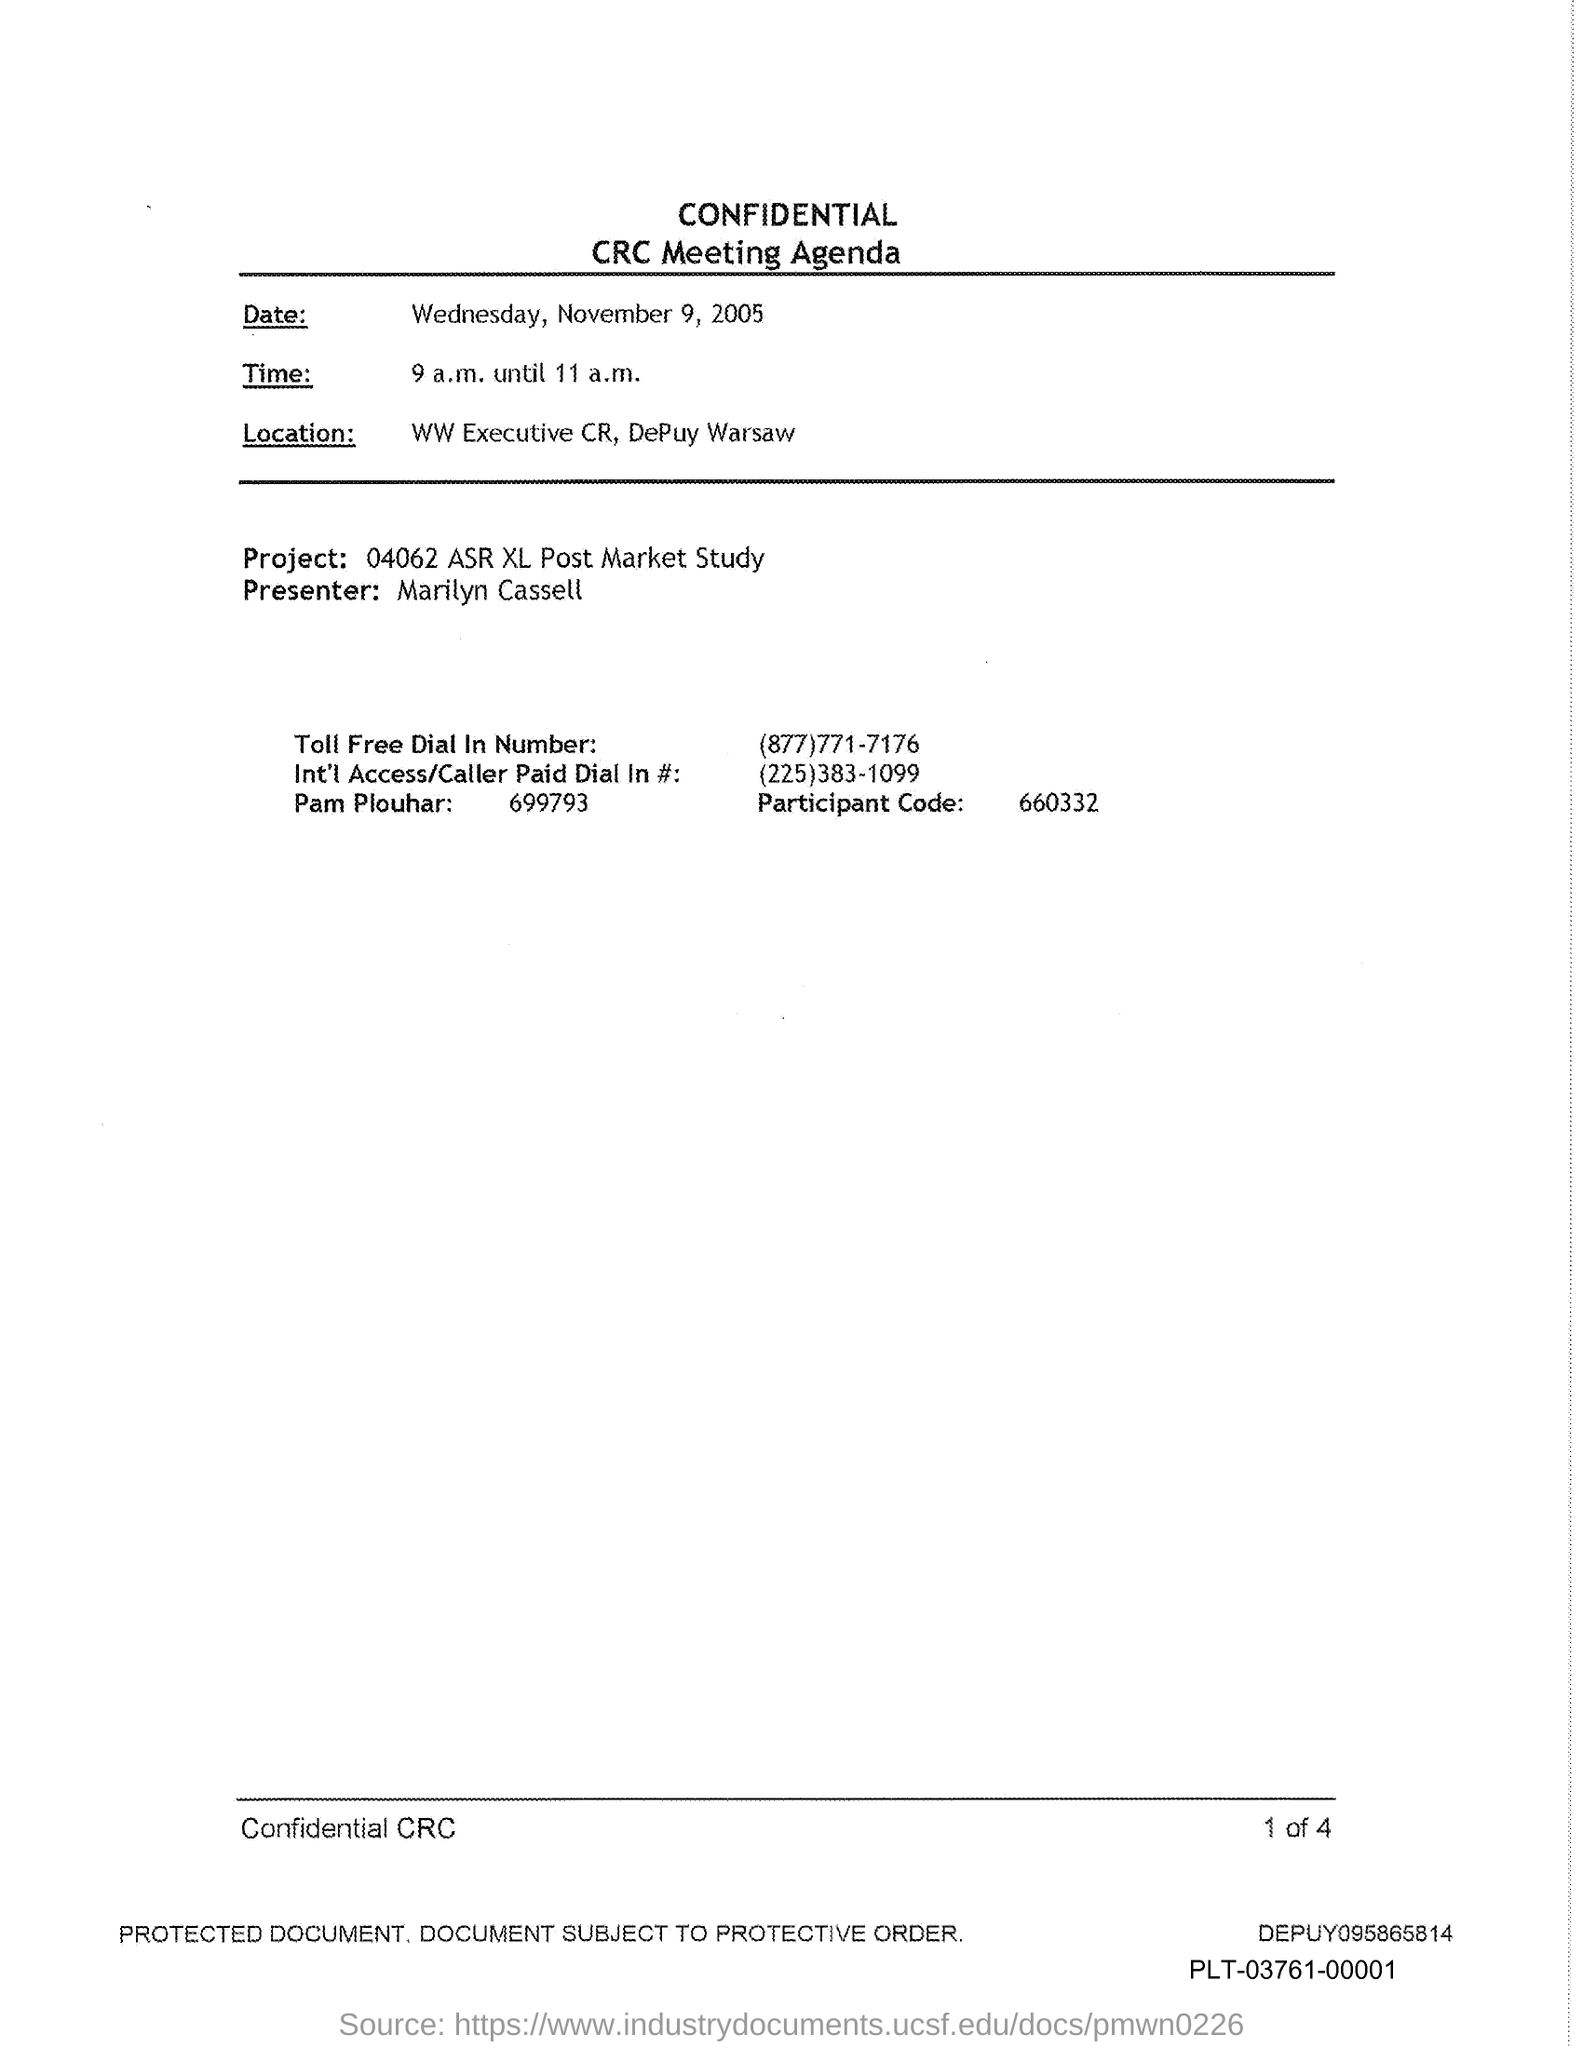Specify some key components in this picture. The presenter is Marilyn Cassell. The Participant Code is 660332. 